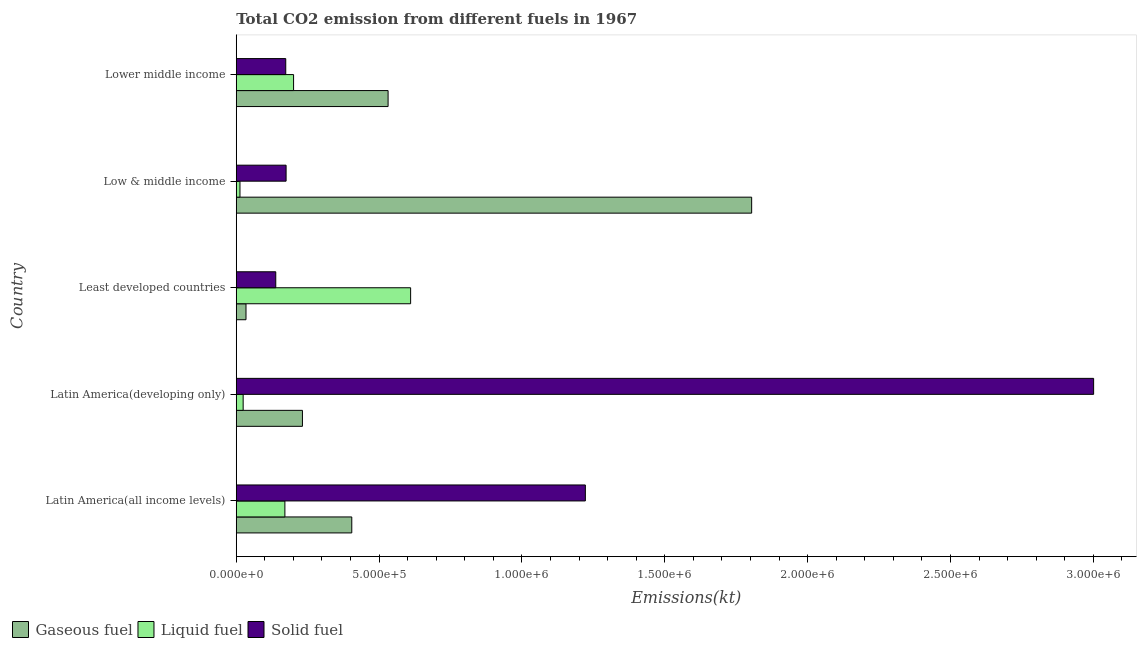What is the label of the 4th group of bars from the top?
Make the answer very short. Latin America(developing only). In how many cases, is the number of bars for a given country not equal to the number of legend labels?
Keep it short and to the point. 0. What is the amount of co2 emissions from gaseous fuel in Latin America(all income levels)?
Ensure brevity in your answer.  4.04e+05. Across all countries, what is the maximum amount of co2 emissions from liquid fuel?
Your answer should be compact. 6.10e+05. Across all countries, what is the minimum amount of co2 emissions from gaseous fuel?
Your response must be concise. 3.41e+04. In which country was the amount of co2 emissions from gaseous fuel maximum?
Offer a terse response. Low & middle income. What is the total amount of co2 emissions from gaseous fuel in the graph?
Make the answer very short. 3.01e+06. What is the difference between the amount of co2 emissions from solid fuel in Low & middle income and that in Lower middle income?
Keep it short and to the point. 1213.44. What is the difference between the amount of co2 emissions from solid fuel in Latin America(developing only) and the amount of co2 emissions from liquid fuel in Lower middle income?
Offer a very short reply. 2.80e+06. What is the average amount of co2 emissions from gaseous fuel per country?
Keep it short and to the point. 6.01e+05. What is the difference between the amount of co2 emissions from liquid fuel and amount of co2 emissions from gaseous fuel in Low & middle income?
Your answer should be very brief. -1.79e+06. In how many countries, is the amount of co2 emissions from solid fuel greater than 2600000 kt?
Offer a terse response. 1. What is the ratio of the amount of co2 emissions from gaseous fuel in Latin America(all income levels) to that in Latin America(developing only)?
Keep it short and to the point. 1.75. Is the amount of co2 emissions from gaseous fuel in Latin America(all income levels) less than that in Latin America(developing only)?
Provide a succinct answer. No. What is the difference between the highest and the second highest amount of co2 emissions from solid fuel?
Give a very brief answer. 1.78e+06. What is the difference between the highest and the lowest amount of co2 emissions from gaseous fuel?
Provide a short and direct response. 1.77e+06. In how many countries, is the amount of co2 emissions from liquid fuel greater than the average amount of co2 emissions from liquid fuel taken over all countries?
Offer a terse response. 1. What does the 2nd bar from the top in Lower middle income represents?
Provide a short and direct response. Liquid fuel. What does the 3rd bar from the bottom in Lower middle income represents?
Give a very brief answer. Solid fuel. Are the values on the major ticks of X-axis written in scientific E-notation?
Ensure brevity in your answer.  Yes. How many legend labels are there?
Your answer should be compact. 3. How are the legend labels stacked?
Keep it short and to the point. Horizontal. What is the title of the graph?
Ensure brevity in your answer.  Total CO2 emission from different fuels in 1967. What is the label or title of the X-axis?
Ensure brevity in your answer.  Emissions(kt). What is the label or title of the Y-axis?
Provide a succinct answer. Country. What is the Emissions(kt) of Gaseous fuel in Latin America(all income levels)?
Offer a very short reply. 4.04e+05. What is the Emissions(kt) in Liquid fuel in Latin America(all income levels)?
Offer a terse response. 1.70e+05. What is the Emissions(kt) in Solid fuel in Latin America(all income levels)?
Offer a terse response. 1.22e+06. What is the Emissions(kt) of Gaseous fuel in Latin America(developing only)?
Provide a short and direct response. 2.32e+05. What is the Emissions(kt) in Liquid fuel in Latin America(developing only)?
Provide a short and direct response. 2.41e+04. What is the Emissions(kt) in Solid fuel in Latin America(developing only)?
Provide a short and direct response. 3.00e+06. What is the Emissions(kt) in Gaseous fuel in Least developed countries?
Provide a short and direct response. 3.41e+04. What is the Emissions(kt) in Liquid fuel in Least developed countries?
Your answer should be very brief. 6.10e+05. What is the Emissions(kt) of Solid fuel in Least developed countries?
Provide a succinct answer. 1.38e+05. What is the Emissions(kt) of Gaseous fuel in Low & middle income?
Provide a succinct answer. 1.80e+06. What is the Emissions(kt) of Liquid fuel in Low & middle income?
Your response must be concise. 1.30e+04. What is the Emissions(kt) of Solid fuel in Low & middle income?
Offer a terse response. 1.74e+05. What is the Emissions(kt) of Gaseous fuel in Lower middle income?
Offer a very short reply. 5.31e+05. What is the Emissions(kt) in Liquid fuel in Lower middle income?
Your response must be concise. 2.01e+05. What is the Emissions(kt) of Solid fuel in Lower middle income?
Ensure brevity in your answer.  1.73e+05. Across all countries, what is the maximum Emissions(kt) of Gaseous fuel?
Make the answer very short. 1.80e+06. Across all countries, what is the maximum Emissions(kt) in Liquid fuel?
Your answer should be very brief. 6.10e+05. Across all countries, what is the maximum Emissions(kt) of Solid fuel?
Your answer should be compact. 3.00e+06. Across all countries, what is the minimum Emissions(kt) of Gaseous fuel?
Provide a succinct answer. 3.41e+04. Across all countries, what is the minimum Emissions(kt) in Liquid fuel?
Provide a succinct answer. 1.30e+04. Across all countries, what is the minimum Emissions(kt) of Solid fuel?
Offer a terse response. 1.38e+05. What is the total Emissions(kt) in Gaseous fuel in the graph?
Provide a succinct answer. 3.01e+06. What is the total Emissions(kt) in Liquid fuel in the graph?
Your answer should be compact. 1.02e+06. What is the total Emissions(kt) in Solid fuel in the graph?
Offer a very short reply. 4.71e+06. What is the difference between the Emissions(kt) of Gaseous fuel in Latin America(all income levels) and that in Latin America(developing only)?
Ensure brevity in your answer.  1.73e+05. What is the difference between the Emissions(kt) in Liquid fuel in Latin America(all income levels) and that in Latin America(developing only)?
Give a very brief answer. 1.46e+05. What is the difference between the Emissions(kt) of Solid fuel in Latin America(all income levels) and that in Latin America(developing only)?
Offer a very short reply. -1.78e+06. What is the difference between the Emissions(kt) in Gaseous fuel in Latin America(all income levels) and that in Least developed countries?
Your response must be concise. 3.70e+05. What is the difference between the Emissions(kt) in Liquid fuel in Latin America(all income levels) and that in Least developed countries?
Offer a terse response. -4.40e+05. What is the difference between the Emissions(kt) of Solid fuel in Latin America(all income levels) and that in Least developed countries?
Give a very brief answer. 1.08e+06. What is the difference between the Emissions(kt) in Gaseous fuel in Latin America(all income levels) and that in Low & middle income?
Provide a succinct answer. -1.40e+06. What is the difference between the Emissions(kt) in Liquid fuel in Latin America(all income levels) and that in Low & middle income?
Your answer should be very brief. 1.57e+05. What is the difference between the Emissions(kt) in Solid fuel in Latin America(all income levels) and that in Low & middle income?
Your answer should be very brief. 1.05e+06. What is the difference between the Emissions(kt) of Gaseous fuel in Latin America(all income levels) and that in Lower middle income?
Keep it short and to the point. -1.27e+05. What is the difference between the Emissions(kt) of Liquid fuel in Latin America(all income levels) and that in Lower middle income?
Make the answer very short. -3.04e+04. What is the difference between the Emissions(kt) of Solid fuel in Latin America(all income levels) and that in Lower middle income?
Ensure brevity in your answer.  1.05e+06. What is the difference between the Emissions(kt) of Gaseous fuel in Latin America(developing only) and that in Least developed countries?
Offer a very short reply. 1.98e+05. What is the difference between the Emissions(kt) of Liquid fuel in Latin America(developing only) and that in Least developed countries?
Keep it short and to the point. -5.86e+05. What is the difference between the Emissions(kt) in Solid fuel in Latin America(developing only) and that in Least developed countries?
Your answer should be very brief. 2.86e+06. What is the difference between the Emissions(kt) of Gaseous fuel in Latin America(developing only) and that in Low & middle income?
Make the answer very short. -1.57e+06. What is the difference between the Emissions(kt) of Liquid fuel in Latin America(developing only) and that in Low & middle income?
Offer a very short reply. 1.12e+04. What is the difference between the Emissions(kt) in Solid fuel in Latin America(developing only) and that in Low & middle income?
Provide a short and direct response. 2.83e+06. What is the difference between the Emissions(kt) of Gaseous fuel in Latin America(developing only) and that in Lower middle income?
Your answer should be very brief. -3.00e+05. What is the difference between the Emissions(kt) of Liquid fuel in Latin America(developing only) and that in Lower middle income?
Provide a succinct answer. -1.77e+05. What is the difference between the Emissions(kt) of Solid fuel in Latin America(developing only) and that in Lower middle income?
Your answer should be very brief. 2.83e+06. What is the difference between the Emissions(kt) in Gaseous fuel in Least developed countries and that in Low & middle income?
Ensure brevity in your answer.  -1.77e+06. What is the difference between the Emissions(kt) of Liquid fuel in Least developed countries and that in Low & middle income?
Provide a short and direct response. 5.97e+05. What is the difference between the Emissions(kt) in Solid fuel in Least developed countries and that in Low & middle income?
Give a very brief answer. -3.62e+04. What is the difference between the Emissions(kt) in Gaseous fuel in Least developed countries and that in Lower middle income?
Make the answer very short. -4.97e+05. What is the difference between the Emissions(kt) of Liquid fuel in Least developed countries and that in Lower middle income?
Make the answer very short. 4.10e+05. What is the difference between the Emissions(kt) in Solid fuel in Least developed countries and that in Lower middle income?
Your answer should be compact. -3.50e+04. What is the difference between the Emissions(kt) in Gaseous fuel in Low & middle income and that in Lower middle income?
Your answer should be very brief. 1.27e+06. What is the difference between the Emissions(kt) in Liquid fuel in Low & middle income and that in Lower middle income?
Provide a succinct answer. -1.88e+05. What is the difference between the Emissions(kt) of Solid fuel in Low & middle income and that in Lower middle income?
Offer a terse response. 1213.44. What is the difference between the Emissions(kt) of Gaseous fuel in Latin America(all income levels) and the Emissions(kt) of Liquid fuel in Latin America(developing only)?
Give a very brief answer. 3.80e+05. What is the difference between the Emissions(kt) in Gaseous fuel in Latin America(all income levels) and the Emissions(kt) in Solid fuel in Latin America(developing only)?
Provide a succinct answer. -2.60e+06. What is the difference between the Emissions(kt) in Liquid fuel in Latin America(all income levels) and the Emissions(kt) in Solid fuel in Latin America(developing only)?
Offer a terse response. -2.83e+06. What is the difference between the Emissions(kt) of Gaseous fuel in Latin America(all income levels) and the Emissions(kt) of Liquid fuel in Least developed countries?
Your answer should be very brief. -2.06e+05. What is the difference between the Emissions(kt) in Gaseous fuel in Latin America(all income levels) and the Emissions(kt) in Solid fuel in Least developed countries?
Ensure brevity in your answer.  2.66e+05. What is the difference between the Emissions(kt) in Liquid fuel in Latin America(all income levels) and the Emissions(kt) in Solid fuel in Least developed countries?
Offer a terse response. 3.20e+04. What is the difference between the Emissions(kt) in Gaseous fuel in Latin America(all income levels) and the Emissions(kt) in Liquid fuel in Low & middle income?
Offer a very short reply. 3.91e+05. What is the difference between the Emissions(kt) in Gaseous fuel in Latin America(all income levels) and the Emissions(kt) in Solid fuel in Low & middle income?
Make the answer very short. 2.30e+05. What is the difference between the Emissions(kt) of Liquid fuel in Latin America(all income levels) and the Emissions(kt) of Solid fuel in Low & middle income?
Make the answer very short. -4229.37. What is the difference between the Emissions(kt) in Gaseous fuel in Latin America(all income levels) and the Emissions(kt) in Liquid fuel in Lower middle income?
Offer a terse response. 2.04e+05. What is the difference between the Emissions(kt) in Gaseous fuel in Latin America(all income levels) and the Emissions(kt) in Solid fuel in Lower middle income?
Give a very brief answer. 2.31e+05. What is the difference between the Emissions(kt) in Liquid fuel in Latin America(all income levels) and the Emissions(kt) in Solid fuel in Lower middle income?
Ensure brevity in your answer.  -3015.93. What is the difference between the Emissions(kt) in Gaseous fuel in Latin America(developing only) and the Emissions(kt) in Liquid fuel in Least developed countries?
Offer a very short reply. -3.79e+05. What is the difference between the Emissions(kt) in Gaseous fuel in Latin America(developing only) and the Emissions(kt) in Solid fuel in Least developed countries?
Your answer should be very brief. 9.34e+04. What is the difference between the Emissions(kt) of Liquid fuel in Latin America(developing only) and the Emissions(kt) of Solid fuel in Least developed countries?
Ensure brevity in your answer.  -1.14e+05. What is the difference between the Emissions(kt) in Gaseous fuel in Latin America(developing only) and the Emissions(kt) in Liquid fuel in Low & middle income?
Your answer should be compact. 2.19e+05. What is the difference between the Emissions(kt) of Gaseous fuel in Latin America(developing only) and the Emissions(kt) of Solid fuel in Low & middle income?
Your answer should be compact. 5.72e+04. What is the difference between the Emissions(kt) of Liquid fuel in Latin America(developing only) and the Emissions(kt) of Solid fuel in Low & middle income?
Ensure brevity in your answer.  -1.50e+05. What is the difference between the Emissions(kt) in Gaseous fuel in Latin America(developing only) and the Emissions(kt) in Liquid fuel in Lower middle income?
Ensure brevity in your answer.  3.10e+04. What is the difference between the Emissions(kt) of Gaseous fuel in Latin America(developing only) and the Emissions(kt) of Solid fuel in Lower middle income?
Ensure brevity in your answer.  5.84e+04. What is the difference between the Emissions(kt) of Liquid fuel in Latin America(developing only) and the Emissions(kt) of Solid fuel in Lower middle income?
Provide a short and direct response. -1.49e+05. What is the difference between the Emissions(kt) of Gaseous fuel in Least developed countries and the Emissions(kt) of Liquid fuel in Low & middle income?
Your answer should be compact. 2.11e+04. What is the difference between the Emissions(kt) of Gaseous fuel in Least developed countries and the Emissions(kt) of Solid fuel in Low & middle income?
Ensure brevity in your answer.  -1.40e+05. What is the difference between the Emissions(kt) of Liquid fuel in Least developed countries and the Emissions(kt) of Solid fuel in Low & middle income?
Provide a short and direct response. 4.36e+05. What is the difference between the Emissions(kt) in Gaseous fuel in Least developed countries and the Emissions(kt) in Liquid fuel in Lower middle income?
Give a very brief answer. -1.67e+05. What is the difference between the Emissions(kt) of Gaseous fuel in Least developed countries and the Emissions(kt) of Solid fuel in Lower middle income?
Keep it short and to the point. -1.39e+05. What is the difference between the Emissions(kt) in Liquid fuel in Least developed countries and the Emissions(kt) in Solid fuel in Lower middle income?
Provide a short and direct response. 4.37e+05. What is the difference between the Emissions(kt) in Gaseous fuel in Low & middle income and the Emissions(kt) in Liquid fuel in Lower middle income?
Offer a terse response. 1.60e+06. What is the difference between the Emissions(kt) of Gaseous fuel in Low & middle income and the Emissions(kt) of Solid fuel in Lower middle income?
Offer a very short reply. 1.63e+06. What is the difference between the Emissions(kt) in Liquid fuel in Low & middle income and the Emissions(kt) in Solid fuel in Lower middle income?
Keep it short and to the point. -1.60e+05. What is the average Emissions(kt) in Gaseous fuel per country?
Your response must be concise. 6.01e+05. What is the average Emissions(kt) of Liquid fuel per country?
Your response must be concise. 2.04e+05. What is the average Emissions(kt) of Solid fuel per country?
Your answer should be compact. 9.42e+05. What is the difference between the Emissions(kt) in Gaseous fuel and Emissions(kt) in Liquid fuel in Latin America(all income levels)?
Provide a short and direct response. 2.34e+05. What is the difference between the Emissions(kt) in Gaseous fuel and Emissions(kt) in Solid fuel in Latin America(all income levels)?
Ensure brevity in your answer.  -8.18e+05. What is the difference between the Emissions(kt) in Liquid fuel and Emissions(kt) in Solid fuel in Latin America(all income levels)?
Ensure brevity in your answer.  -1.05e+06. What is the difference between the Emissions(kt) of Gaseous fuel and Emissions(kt) of Liquid fuel in Latin America(developing only)?
Offer a very short reply. 2.08e+05. What is the difference between the Emissions(kt) in Gaseous fuel and Emissions(kt) in Solid fuel in Latin America(developing only)?
Your answer should be very brief. -2.77e+06. What is the difference between the Emissions(kt) of Liquid fuel and Emissions(kt) of Solid fuel in Latin America(developing only)?
Your answer should be very brief. -2.98e+06. What is the difference between the Emissions(kt) in Gaseous fuel and Emissions(kt) in Liquid fuel in Least developed countries?
Your answer should be compact. -5.76e+05. What is the difference between the Emissions(kt) in Gaseous fuel and Emissions(kt) in Solid fuel in Least developed countries?
Offer a terse response. -1.04e+05. What is the difference between the Emissions(kt) of Liquid fuel and Emissions(kt) of Solid fuel in Least developed countries?
Your response must be concise. 4.72e+05. What is the difference between the Emissions(kt) in Gaseous fuel and Emissions(kt) in Liquid fuel in Low & middle income?
Offer a terse response. 1.79e+06. What is the difference between the Emissions(kt) of Gaseous fuel and Emissions(kt) of Solid fuel in Low & middle income?
Offer a terse response. 1.63e+06. What is the difference between the Emissions(kt) in Liquid fuel and Emissions(kt) in Solid fuel in Low & middle income?
Provide a short and direct response. -1.61e+05. What is the difference between the Emissions(kt) in Gaseous fuel and Emissions(kt) in Liquid fuel in Lower middle income?
Your answer should be very brief. 3.31e+05. What is the difference between the Emissions(kt) in Gaseous fuel and Emissions(kt) in Solid fuel in Lower middle income?
Offer a very short reply. 3.58e+05. What is the difference between the Emissions(kt) of Liquid fuel and Emissions(kt) of Solid fuel in Lower middle income?
Offer a very short reply. 2.74e+04. What is the ratio of the Emissions(kt) in Gaseous fuel in Latin America(all income levels) to that in Latin America(developing only)?
Your answer should be compact. 1.75. What is the ratio of the Emissions(kt) of Liquid fuel in Latin America(all income levels) to that in Latin America(developing only)?
Offer a terse response. 7.05. What is the ratio of the Emissions(kt) in Solid fuel in Latin America(all income levels) to that in Latin America(developing only)?
Your response must be concise. 0.41. What is the ratio of the Emissions(kt) of Gaseous fuel in Latin America(all income levels) to that in Least developed countries?
Keep it short and to the point. 11.86. What is the ratio of the Emissions(kt) in Liquid fuel in Latin America(all income levels) to that in Least developed countries?
Your response must be concise. 0.28. What is the ratio of the Emissions(kt) in Solid fuel in Latin America(all income levels) to that in Least developed countries?
Provide a short and direct response. 8.84. What is the ratio of the Emissions(kt) in Gaseous fuel in Latin America(all income levels) to that in Low & middle income?
Give a very brief answer. 0.22. What is the ratio of the Emissions(kt) of Liquid fuel in Latin America(all income levels) to that in Low & middle income?
Ensure brevity in your answer.  13.12. What is the ratio of the Emissions(kt) in Solid fuel in Latin America(all income levels) to that in Low & middle income?
Ensure brevity in your answer.  7. What is the ratio of the Emissions(kt) of Gaseous fuel in Latin America(all income levels) to that in Lower middle income?
Offer a terse response. 0.76. What is the ratio of the Emissions(kt) in Liquid fuel in Latin America(all income levels) to that in Lower middle income?
Your response must be concise. 0.85. What is the ratio of the Emissions(kt) of Solid fuel in Latin America(all income levels) to that in Lower middle income?
Offer a terse response. 7.05. What is the ratio of the Emissions(kt) in Gaseous fuel in Latin America(developing only) to that in Least developed countries?
Ensure brevity in your answer.  6.8. What is the ratio of the Emissions(kt) in Liquid fuel in Latin America(developing only) to that in Least developed countries?
Your response must be concise. 0.04. What is the ratio of the Emissions(kt) in Solid fuel in Latin America(developing only) to that in Least developed countries?
Give a very brief answer. 21.7. What is the ratio of the Emissions(kt) in Gaseous fuel in Latin America(developing only) to that in Low & middle income?
Keep it short and to the point. 0.13. What is the ratio of the Emissions(kt) of Liquid fuel in Latin America(developing only) to that in Low & middle income?
Provide a succinct answer. 1.86. What is the ratio of the Emissions(kt) in Solid fuel in Latin America(developing only) to that in Low & middle income?
Give a very brief answer. 17.2. What is the ratio of the Emissions(kt) of Gaseous fuel in Latin America(developing only) to that in Lower middle income?
Your response must be concise. 0.44. What is the ratio of the Emissions(kt) of Liquid fuel in Latin America(developing only) to that in Lower middle income?
Give a very brief answer. 0.12. What is the ratio of the Emissions(kt) in Solid fuel in Latin America(developing only) to that in Lower middle income?
Your response must be concise. 17.32. What is the ratio of the Emissions(kt) in Gaseous fuel in Least developed countries to that in Low & middle income?
Your answer should be compact. 0.02. What is the ratio of the Emissions(kt) of Liquid fuel in Least developed countries to that in Low & middle income?
Give a very brief answer. 47.03. What is the ratio of the Emissions(kt) in Solid fuel in Least developed countries to that in Low & middle income?
Make the answer very short. 0.79. What is the ratio of the Emissions(kt) in Gaseous fuel in Least developed countries to that in Lower middle income?
Your answer should be very brief. 0.06. What is the ratio of the Emissions(kt) of Liquid fuel in Least developed countries to that in Lower middle income?
Keep it short and to the point. 3.04. What is the ratio of the Emissions(kt) in Solid fuel in Least developed countries to that in Lower middle income?
Give a very brief answer. 0.8. What is the ratio of the Emissions(kt) in Gaseous fuel in Low & middle income to that in Lower middle income?
Make the answer very short. 3.39. What is the ratio of the Emissions(kt) of Liquid fuel in Low & middle income to that in Lower middle income?
Provide a succinct answer. 0.06. What is the difference between the highest and the second highest Emissions(kt) in Gaseous fuel?
Give a very brief answer. 1.27e+06. What is the difference between the highest and the second highest Emissions(kt) of Liquid fuel?
Keep it short and to the point. 4.10e+05. What is the difference between the highest and the second highest Emissions(kt) in Solid fuel?
Offer a terse response. 1.78e+06. What is the difference between the highest and the lowest Emissions(kt) in Gaseous fuel?
Give a very brief answer. 1.77e+06. What is the difference between the highest and the lowest Emissions(kt) in Liquid fuel?
Your answer should be very brief. 5.97e+05. What is the difference between the highest and the lowest Emissions(kt) of Solid fuel?
Your response must be concise. 2.86e+06. 